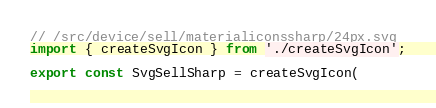<code> <loc_0><loc_0><loc_500><loc_500><_TypeScript_>// /src/device/sell/materialiconssharp/24px.svg
import { createSvgIcon } from './createSvgIcon';

export const SvgSellSharp = createSvgIcon(</code> 